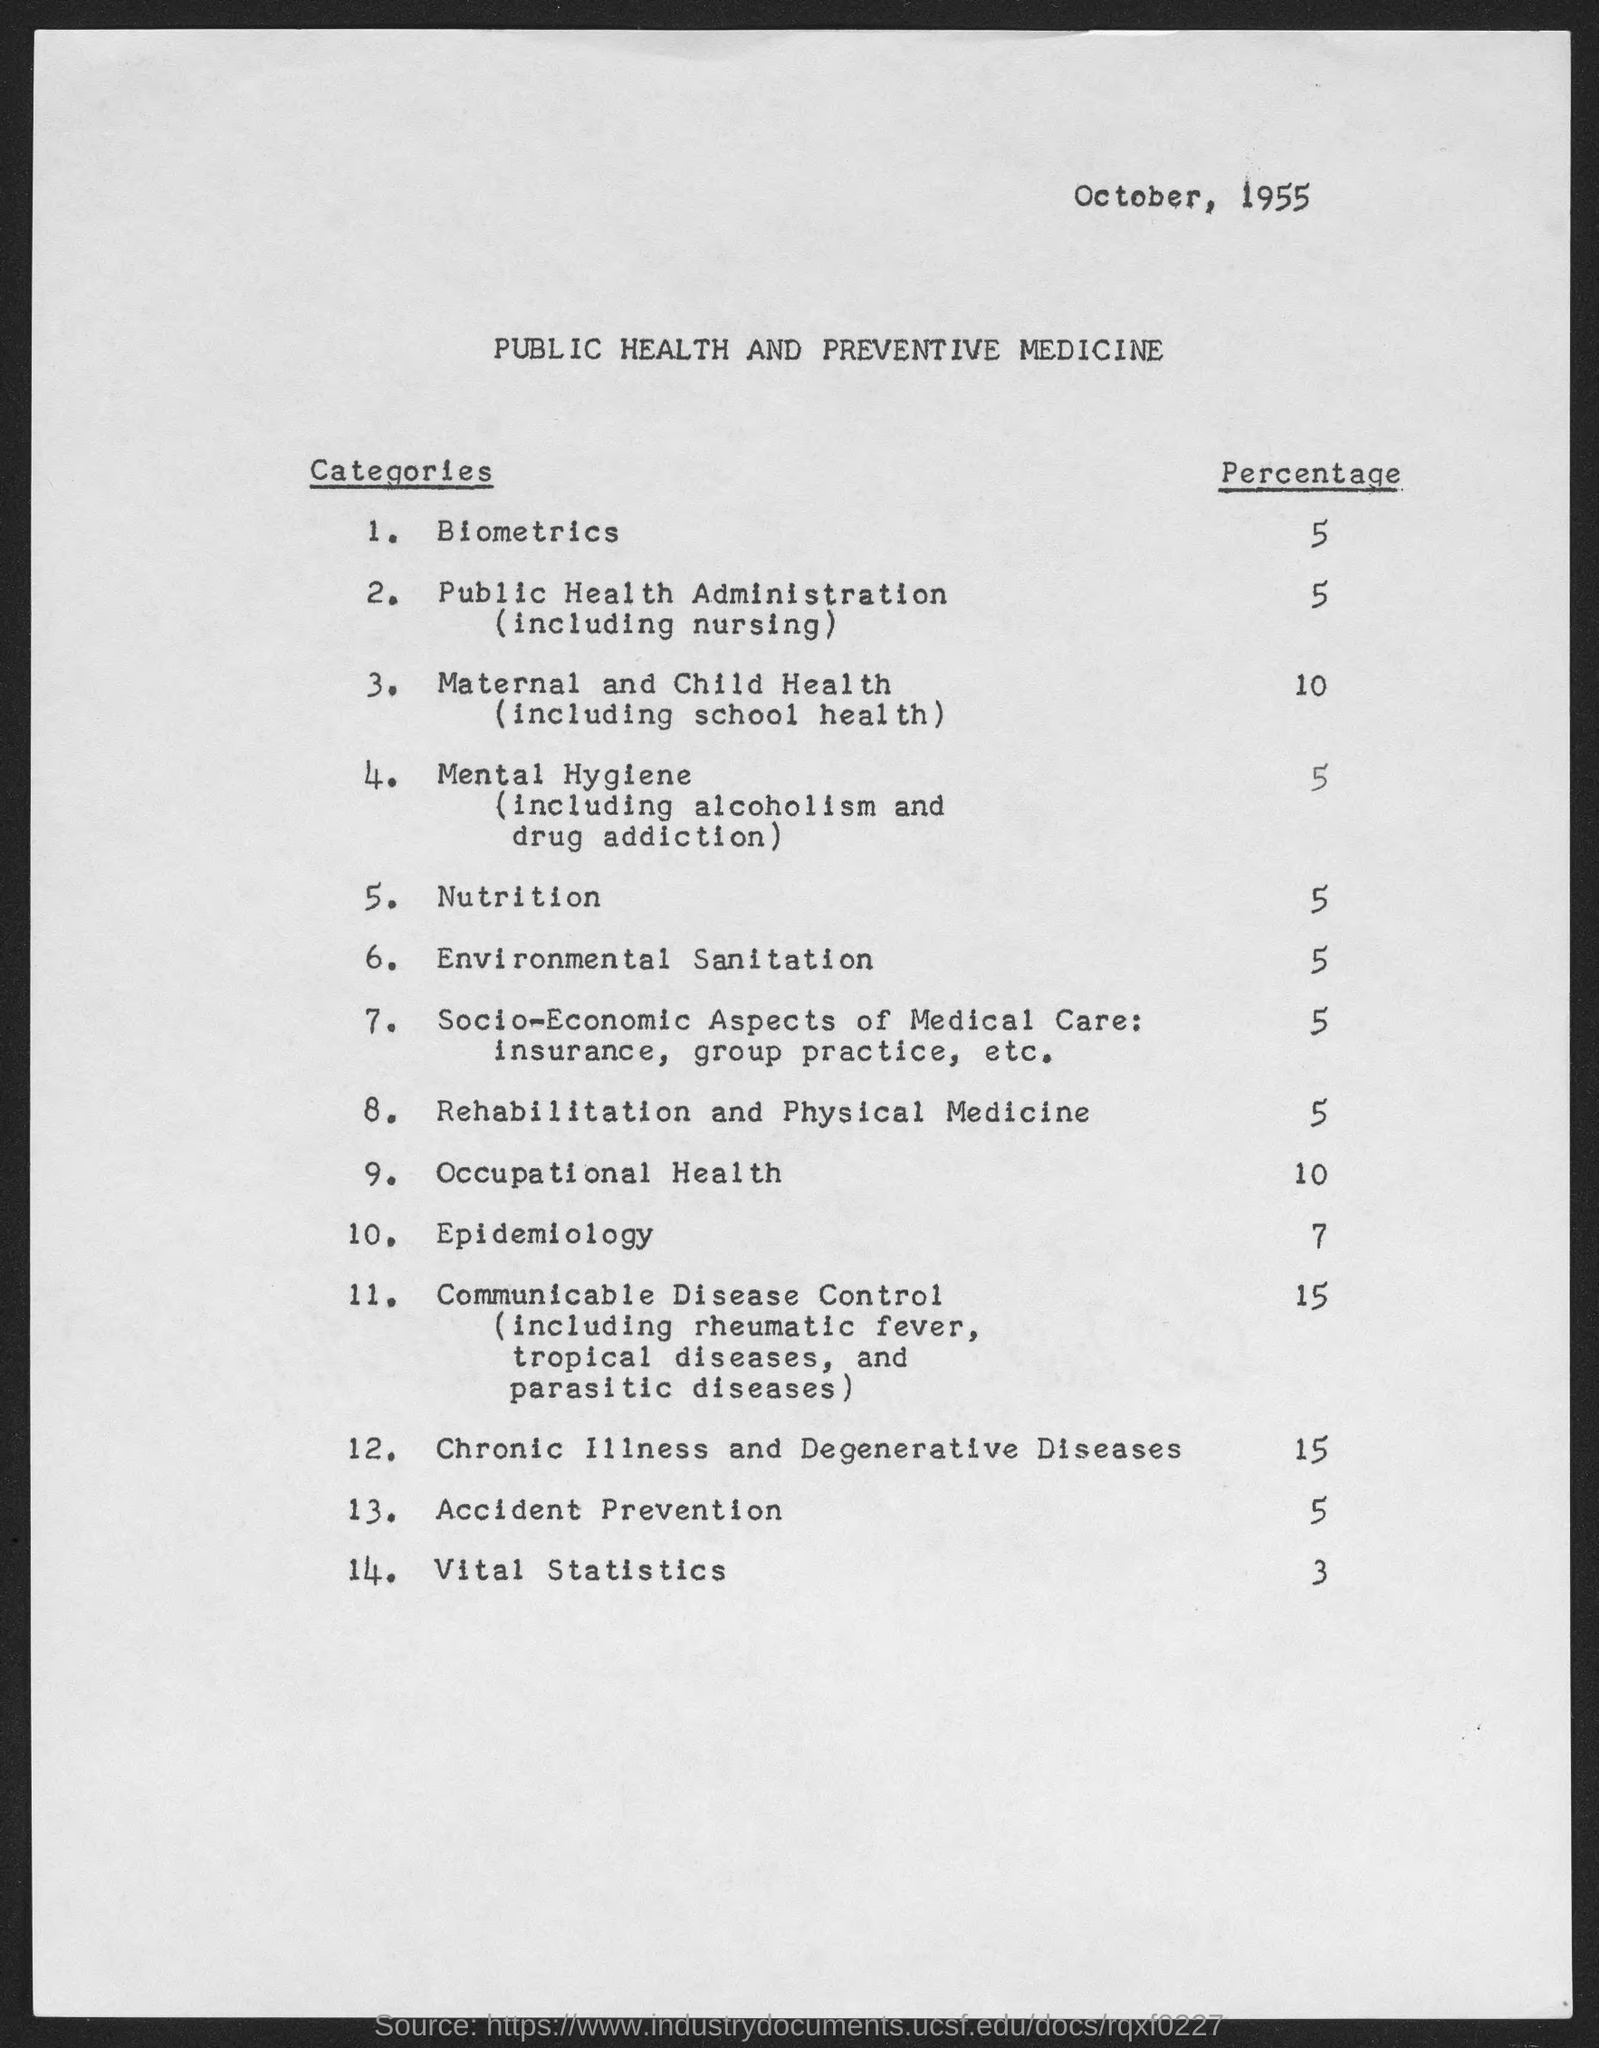Identify some key points in this picture. The percentage of Occupational Health is approximately 10%. The environmental sanitation percentage is 5%. The month and year at the top of the page are October, 1955. The percentage of Maternal and Child Health (including School Health) is 10%. The nutritional content is 5%. 